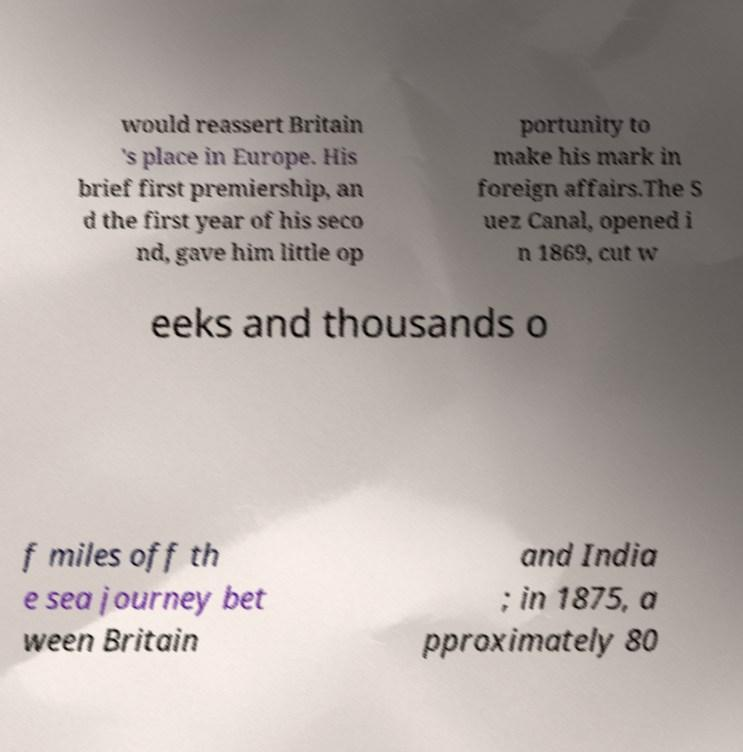Can you read and provide the text displayed in the image?This photo seems to have some interesting text. Can you extract and type it out for me? would reassert Britain 's place in Europe. His brief first premiership, an d the first year of his seco nd, gave him little op portunity to make his mark in foreign affairs.The S uez Canal, opened i n 1869, cut w eeks and thousands o f miles off th e sea journey bet ween Britain and India ; in 1875, a pproximately 80 